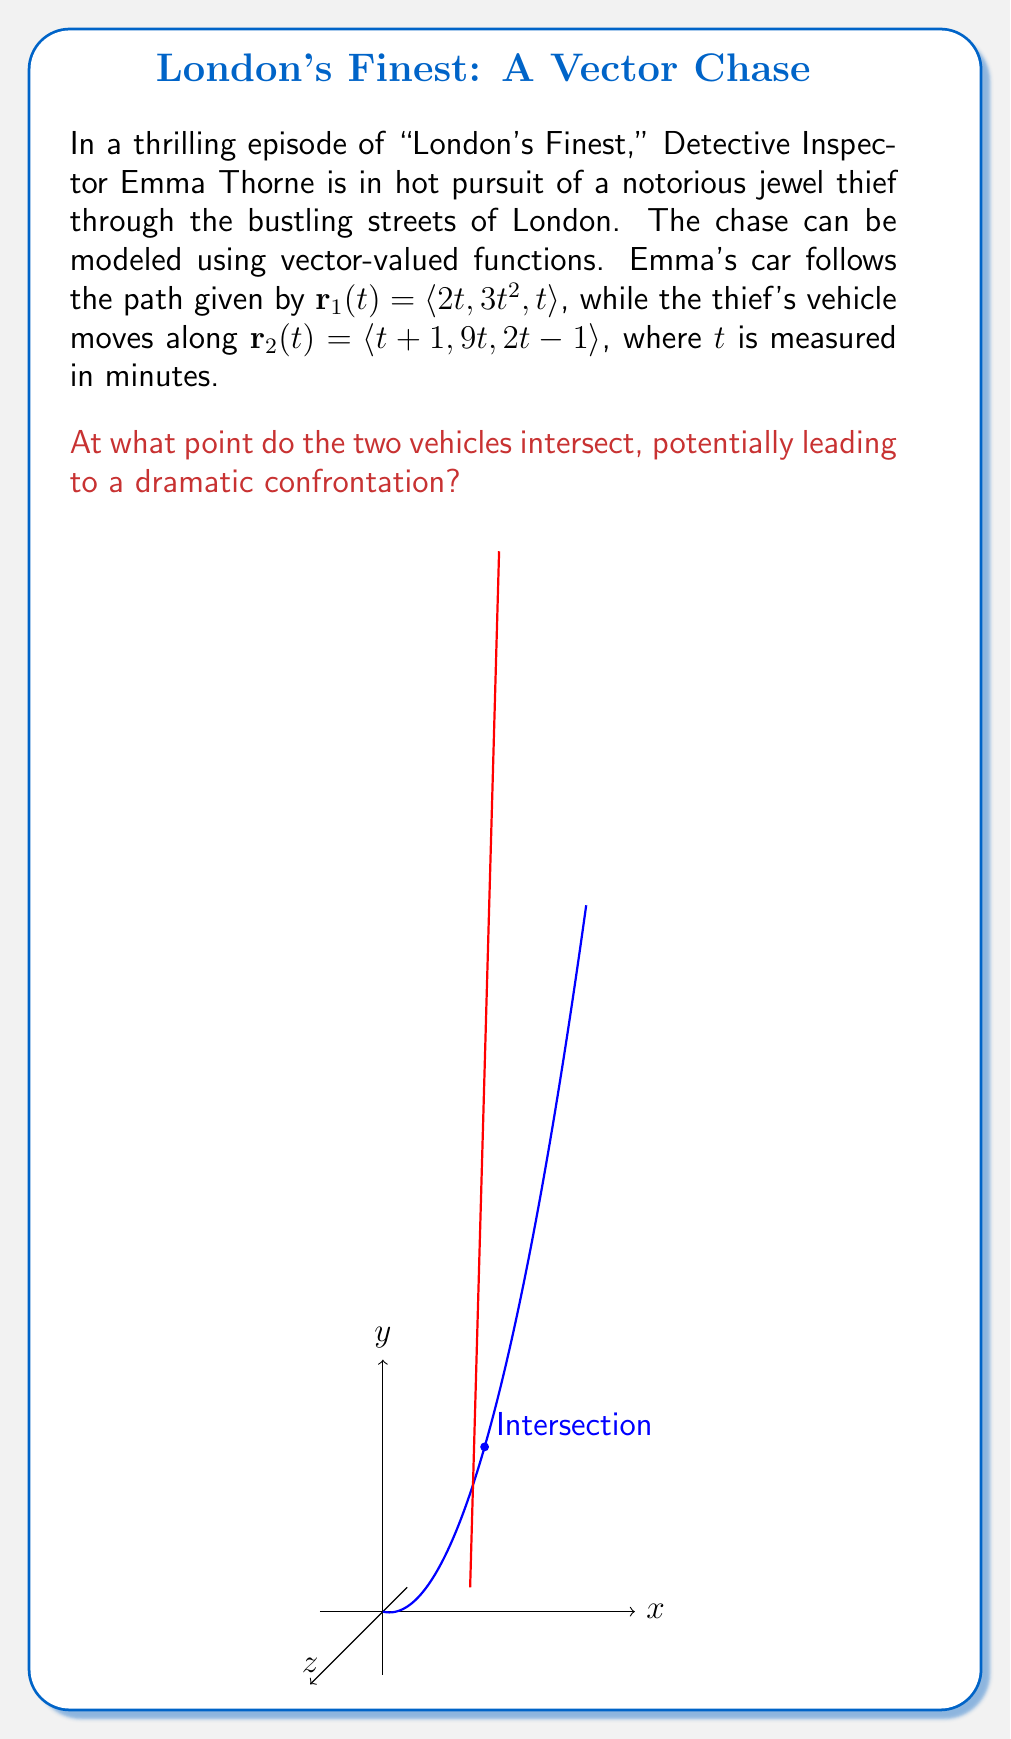Solve this math problem. To find the intersection point, we need to equate the vector-valued functions and solve for $t$:

$$\mathbf{r}_1(t) = \mathbf{r}_2(t)$$

This gives us three equations:

1) $2t = t+1$
2) $3t^2 = 9t$
3) $t = 2t-1$

From equation 1:
$2t = t+1$
$t = 1$

Let's verify this solution in the other equations:

For equation 2:
$3(1)^2 = 9(1)$
$3 = 9$ (This doesn't hold, but we'll continue)

For equation 3:
$1 = 2(1)-1$
$1 = 1$ (This holds)

Since equation 2 doesn't hold for $t=1$, we need to solve it:

$3t^2 = 9t$
$3t^2 - 9t = 0$
$3t(t - 3) = 0$
$t = 0$ or $t = 3$

$t = 0$ doesn't satisfy equations 1 and 3, so we'll use $t = 3$.

Verifying $t = 3$ in all equations:

1) $2(3) = 3+1$
   $6 = 4$ (This doesn't hold)

2) $3(3)^2 = 9(3)$
   $27 = 27$ (This holds)

3) $3 = 2(3)-1$
   $3 = 5$ (This doesn't hold)

We've reached a contradiction. There is no value of $t$ that satisfies all three equations simultaneously. This means the paths of the two vehicles never intersect.

To double-check, we can substitute $t=1$ (which satisfied two of the three equations) into both vector-valued functions:

$\mathbf{r}_1(1) = \langle 2(1), 3(1)^2, 1 \rangle = \langle 2, 3, 1 \rangle$
$\mathbf{r}_2(1) = \langle 1+1, 9(1), 2(1)-1 \rangle = \langle 2, 9, 1 \rangle$

These points are different, confirming that the vehicles do not intersect.
Answer: The vehicles do not intersect. 